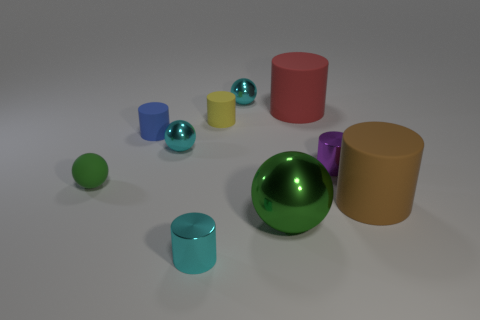Subtract all red cylinders. How many cylinders are left? 5 Subtract all brown cylinders. How many cylinders are left? 5 Subtract 1 cylinders. How many cylinders are left? 5 Subtract all spheres. How many objects are left? 6 Add 7 brown rubber cylinders. How many brown rubber cylinders exist? 8 Subtract 0 purple balls. How many objects are left? 10 Subtract all cyan cylinders. Subtract all blue spheres. How many cylinders are left? 5 Subtract all purple spheres. How many red cylinders are left? 1 Subtract all brown matte objects. Subtract all large cylinders. How many objects are left? 7 Add 5 cyan cylinders. How many cyan cylinders are left? 6 